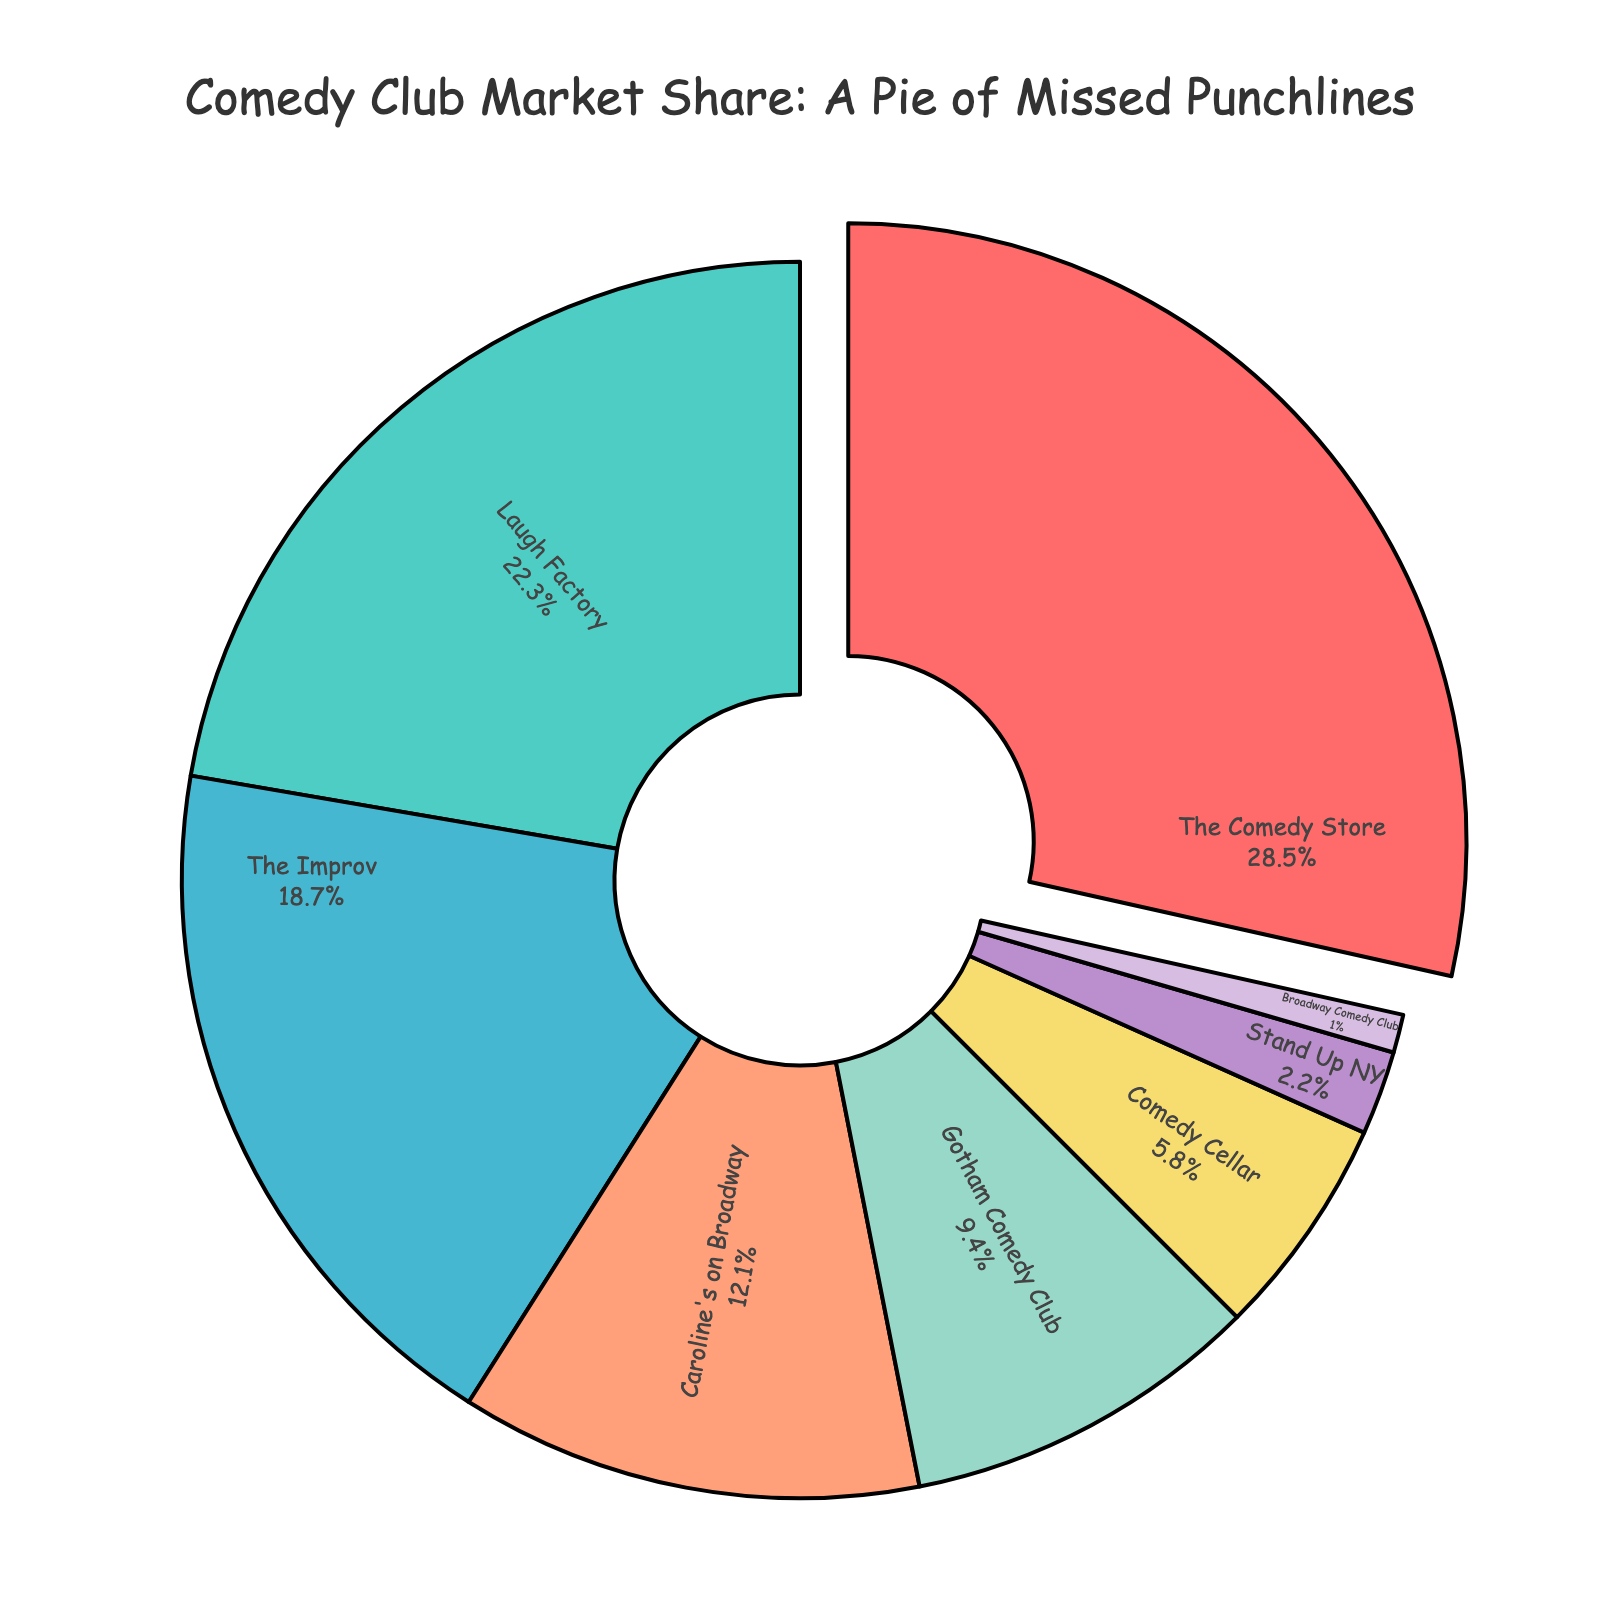Which comedy club has the largest market share? The Comedy Store has the largest segment in the pie chart and is pulled out from the rest.
Answer: The Comedy Store Which two comedy clubs have a combined market share larger than 40%? The Comedy Store (28.5%) and Laugh Factory (22.3%) have a combined market share of 50.8%, which is larger than 40%.
Answer: The Comedy Store and Laugh Factory How much more market share does The Comedy Store have compared to Comedy Cellar? The Comedy Store's market share is 28.5%, and Comedy Cellar's is 5.8%. The difference is 28.5% - 5.8% = 22.7%.
Answer: 22.7% Which comedy club has almost double the market share of Gotham Comedy Club? Caroline's on Broadway has 12.1% market share, which is nearly double that of Gotham Comedy Club's 9.4%.
Answer: Caroline's on Broadway What is the collective market share of The Improv and Gotham Comedy Club? The Improv's market share is 18.7%, and Gotham Comedy Club's is 9.4%. Their combined market share is 18.7% + 9.4% = 28.1%.
Answer: 28.1% Which comedy club has a smaller market share than Stand Up NY but larger than Broadway Comedy Club? Comedy Cellar has a market share of 5.8%, which fits between Stand Up NY's 2.2% and Broadway Comedy Club's 1.0%.
Answer: Comedy Cellar If you sum the market shares of the three smallest clubs, what is the total? The three smallest clubs are Stand Up NY (2.2%), Broadway Comedy Club (1.0%), and Comedy Cellar (5.8%). The total is 2.2% + 1.0% + 5.8% = 9.0%.
Answer: 9.0% Is the market share of The Improv greater than the combined market share of Stand Up NY and Broadway Comedy Club? The Improv's market share is 18.7%, while the combined market share of Stand Up NY (2.2%) and Broadway Comedy Club (1.0%) is 3.2%. 18.7% is greater than 3.2%.
Answer: Yes Which comedy club has the light pink segment in the pie chart? The light pink segment represents The Comedy Store.
Answer: The Comedy Store 